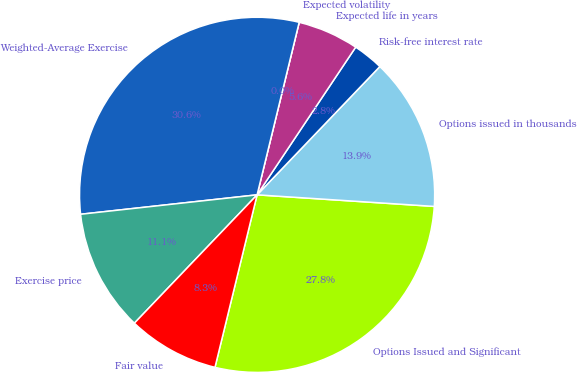Convert chart to OTSL. <chart><loc_0><loc_0><loc_500><loc_500><pie_chart><fcel>Options Issued and Significant<fcel>Options issued in thousands<fcel>Risk-free interest rate<fcel>Expected life in years<fcel>Expected volatility<fcel>Weighted-Average Exercise<fcel>Exercise price<fcel>Fair value<nl><fcel>27.77%<fcel>13.89%<fcel>2.78%<fcel>5.56%<fcel>0.0%<fcel>30.55%<fcel>11.11%<fcel>8.33%<nl></chart> 